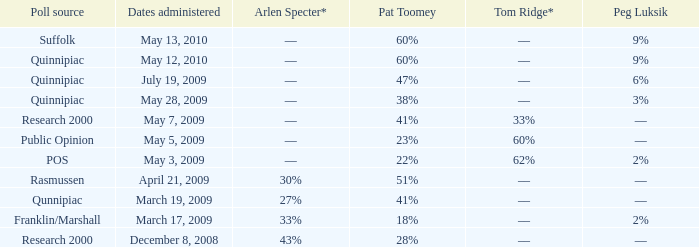Which Poll source has a Peg Luksik of 9%, and Dates administered of may 12, 2010? Quinnipiac. 